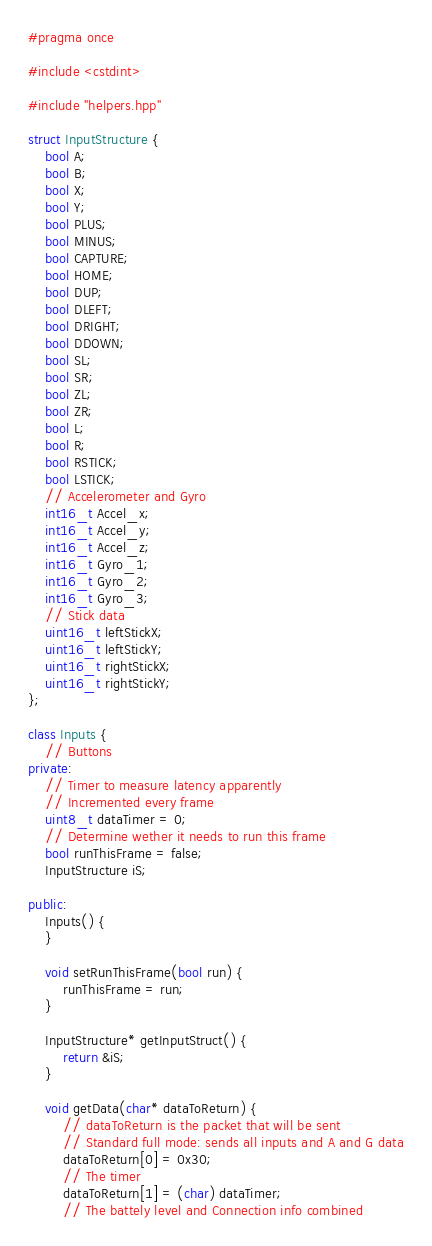<code> <loc_0><loc_0><loc_500><loc_500><_C++_>#pragma once

#include <cstdint>

#include "helpers.hpp"

struct InputStructure {
	bool A;
	bool B;
	bool X;
	bool Y;
	bool PLUS;
	bool MINUS;
	bool CAPTURE;
	bool HOME;
	bool DUP;
	bool DLEFT;
	bool DRIGHT;
	bool DDOWN;
	bool SL;
	bool SR;
	bool ZL;
	bool ZR;
	bool L;
	bool R;
	bool RSTICK;
	bool LSTICK;
	// Accelerometer and Gyro
	int16_t Accel_x;
	int16_t Accel_y;
	int16_t Accel_z;
	int16_t Gyro_1;
	int16_t Gyro_2;
	int16_t Gyro_3;
	// Stick data
	uint16_t leftStickX;
	uint16_t leftStickY;
	uint16_t rightStickX;
	uint16_t rightStickY;
};

class Inputs {
	// Buttons
private:
	// Timer to measure latency apparently
	// Incremented every frame
	uint8_t dataTimer = 0;
	// Determine wether it needs to run this frame
	bool runThisFrame = false;
	InputStructure iS;

public:
	Inputs() {
	}

	void setRunThisFrame(bool run) {
		runThisFrame = run;
	}

	InputStructure* getInputStruct() {
		return &iS;
	}

	void getData(char* dataToReturn) {
		// dataToReturn is the packet that will be sent
		// Standard full mode: sends all inputs and A and G data
		dataToReturn[0] = 0x30;
		// The timer
		dataToReturn[1] = (char) dataTimer;
		// The battely level and Connection info combined</code> 